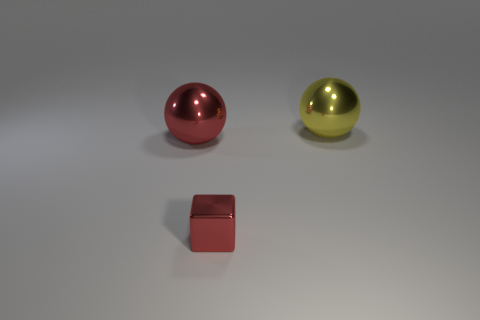Add 1 big red things. How many objects exist? 4 Subtract all balls. How many objects are left? 1 Subtract all blue balls. Subtract all cyan cylinders. How many balls are left? 2 Add 1 large blue shiny cylinders. How many large blue shiny cylinders exist? 1 Subtract 1 red blocks. How many objects are left? 2 Subtract all large purple matte things. Subtract all large yellow things. How many objects are left? 2 Add 2 yellow shiny objects. How many yellow shiny objects are left? 3 